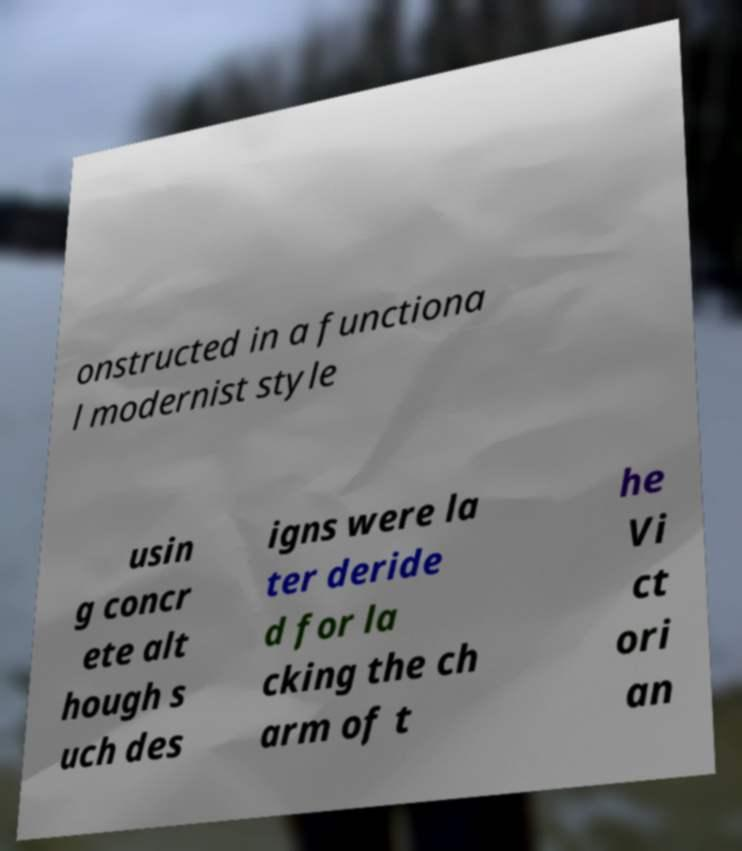I need the written content from this picture converted into text. Can you do that? onstructed in a functiona l modernist style usin g concr ete alt hough s uch des igns were la ter deride d for la cking the ch arm of t he Vi ct ori an 